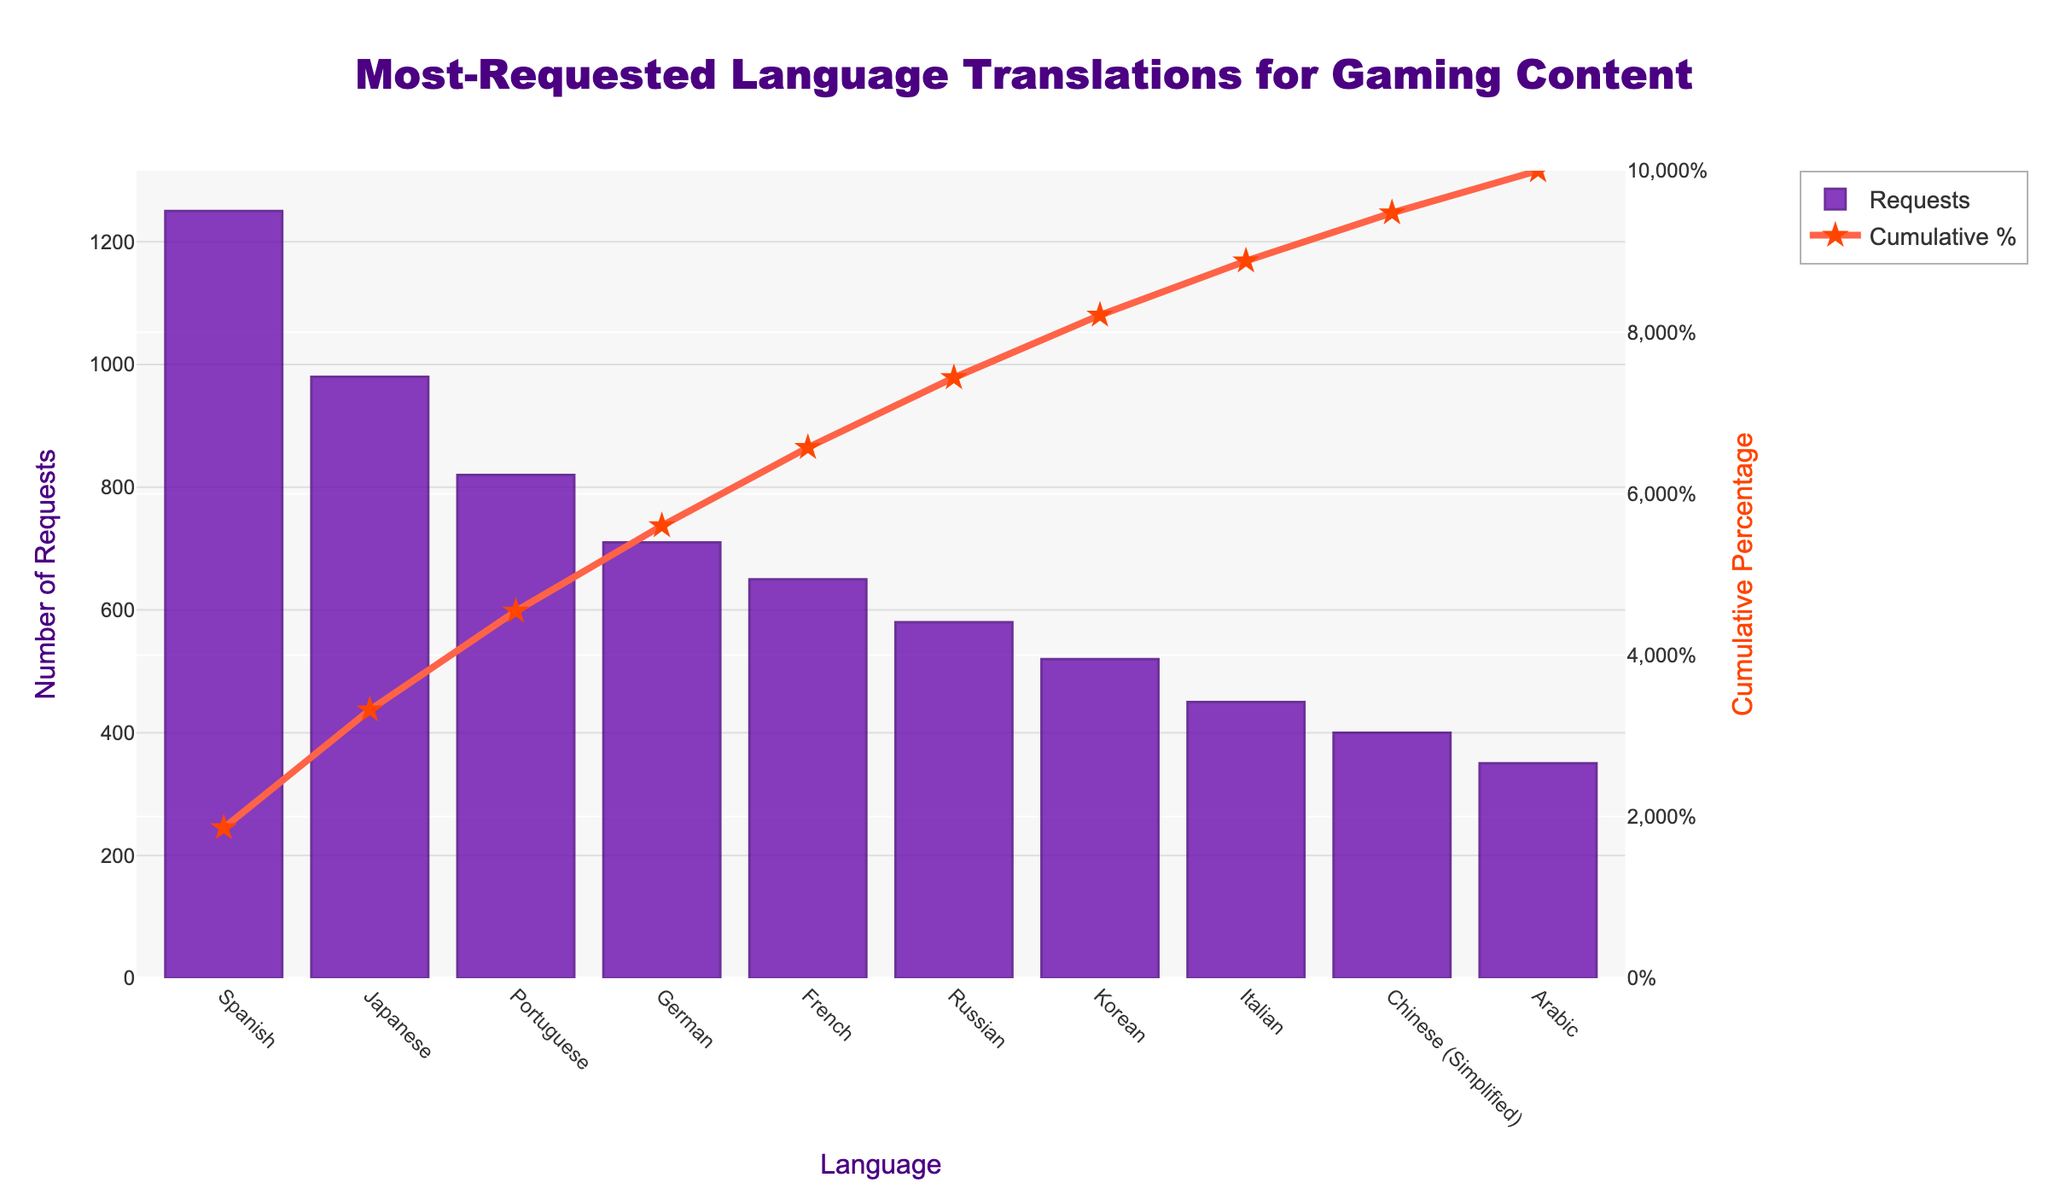What is the most-requested language for gaming content translations? The figure shows the number of requests for various language translations. The language with the highest bar represents the most-requested one.
Answer: Spanish How many requests are there for Japanese translations? On the figure, locate the bar corresponding to Japanese and check its height or the number labeled on it.
Answer: 980 Which language had just over 700 requests for translations? Identify the bar whose height is slightly above 700.
Answer: German What is the cumulative percentage for French translations? Follow the line representing the cumulative percentage to the point where it aligns with the French bar on the x-axis.
Answer: Approximately 73% How many total requests are there for Spanish and Portuguese translations combined? Locate the bars for Spanish and Portuguese, then sum their heights (1250 + 820).
Answer: 2070 Which language has a cumulative percentage closest to 50%? Find the point on the cumulative line closest to 50% and check the corresponding language on the x-axis.
Answer: Portuguese How many languages have more than 500 but less than 1000 requests? Identify the bars with heights between 500 and 1000.
Answer: 4 (Japanese, Portuguese, German, Russian) Which language translation has fewer requests, Italian or Korean? Compare the height of the bars for Italian and Korean.
Answer: Italian What percentage of total requests is accumulated by the top three languages? Add the requests for Spanish, Japanese, and Portuguese and divide by the total sum, then multiply by 100. (1250 + 980 + 820) / (1250 + 980 + 820 + 710 + 650 + 580 + 520 + 450 + 400 + 350) * 100
Answer: Approximately 44% Which languages rank at the 8th and 10th positions in terms of requests? Count the bars from left to right and identify the 8th and 10th bars.
Answer: Italian and Arabic 